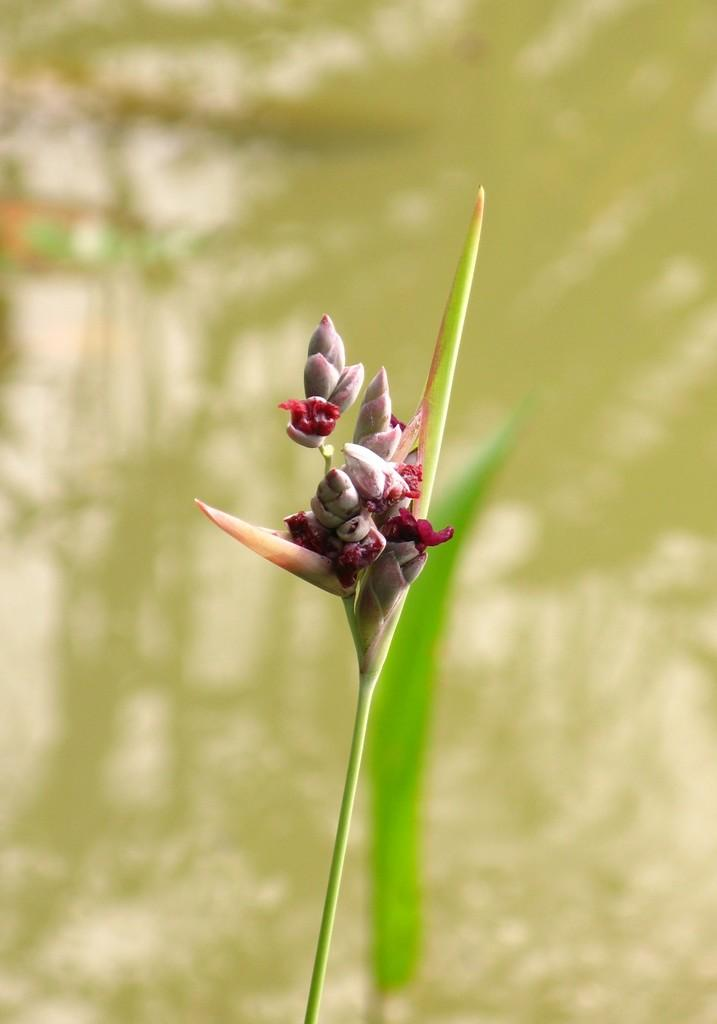What is the main subject in the center of the image? There is a flower in the center of the image. What can be seen in the background of the image? There is water visible in the background of the image. What type of joke is being told by the flower in the image? There is no indication in the image that the flower is telling a joke, as flowers do not have the ability to speak or tell jokes. 